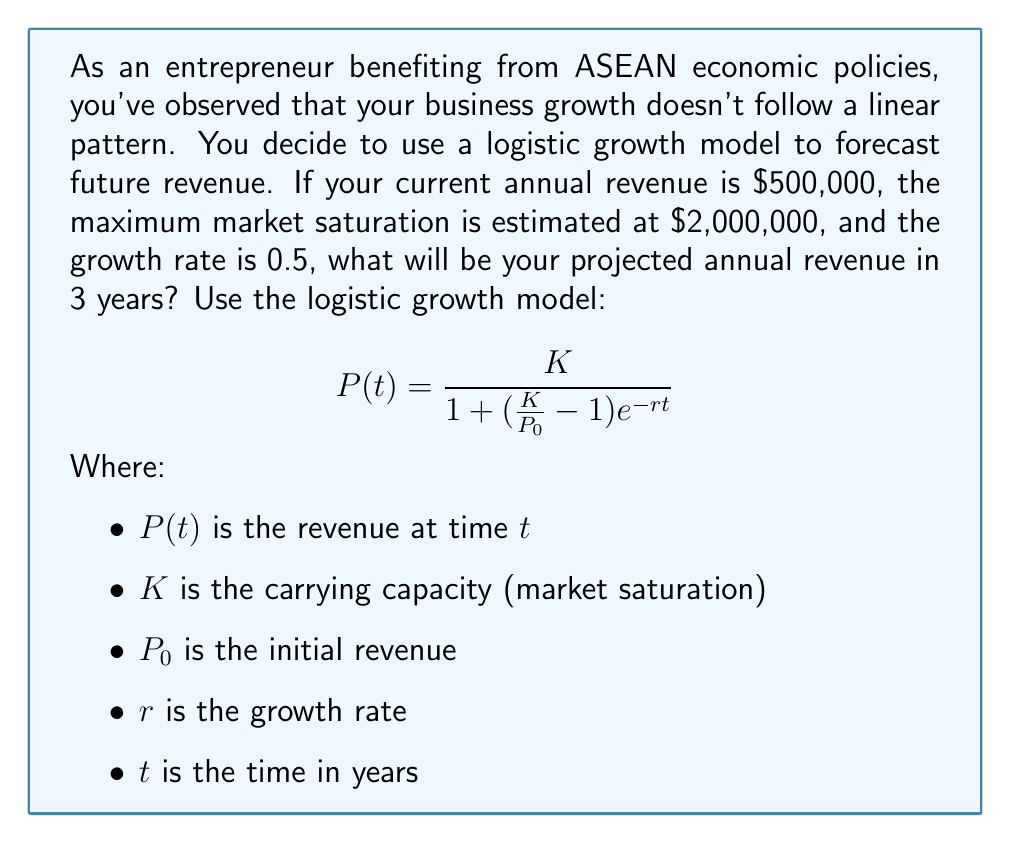Show me your answer to this math problem. Let's approach this step-by-step:

1) We are given:
   $P_0 = 500,000$ (initial revenue)
   $K = 2,000,000$ (market saturation)
   $r = 0.5$ (growth rate)
   $t = 3$ (time in years)

2) Let's substitute these values into the logistic growth model:

   $$P(3) = \frac{2,000,000}{1 + (\frac{2,000,000}{500,000} - 1)e^{-0.5(3)}}$$

3) Simplify the fraction inside the parentheses:

   $$P(3) = \frac{2,000,000}{1 + (4 - 1)e^{-1.5}}$$

4) Calculate $e^{-1.5}$:

   $$e^{-1.5} \approx 0.2231$$

5) Multiply inside the parentheses:

   $$P(3) = \frac{2,000,000}{1 + (3)(0.2231)}$$

6) Simplify:

   $$P(3) = \frac{2,000,000}{1 + 0.6693}$$

7) Calculate the denominator:

   $$P(3) = \frac{2,000,000}{1.6693}$$

8) Divide:

   $$P(3) \approx 1,198,107$$

Therefore, the projected annual revenue in 3 years will be approximately $1,198,107.
Answer: $1,198,107 